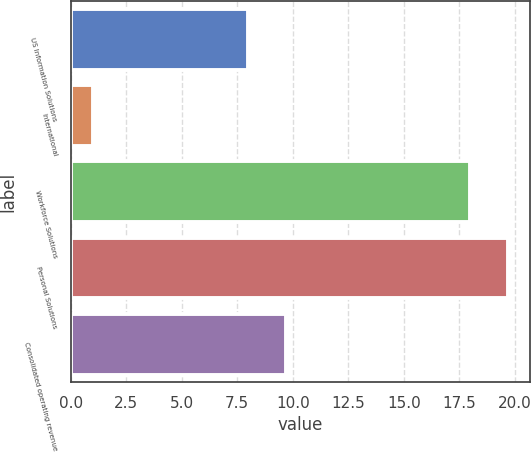Convert chart to OTSL. <chart><loc_0><loc_0><loc_500><loc_500><bar_chart><fcel>US Information Solutions<fcel>International<fcel>Workforce Solutions<fcel>Personal Solutions<fcel>Consolidated operating revenue<nl><fcel>8<fcel>1<fcel>18<fcel>19.7<fcel>9.7<nl></chart> 